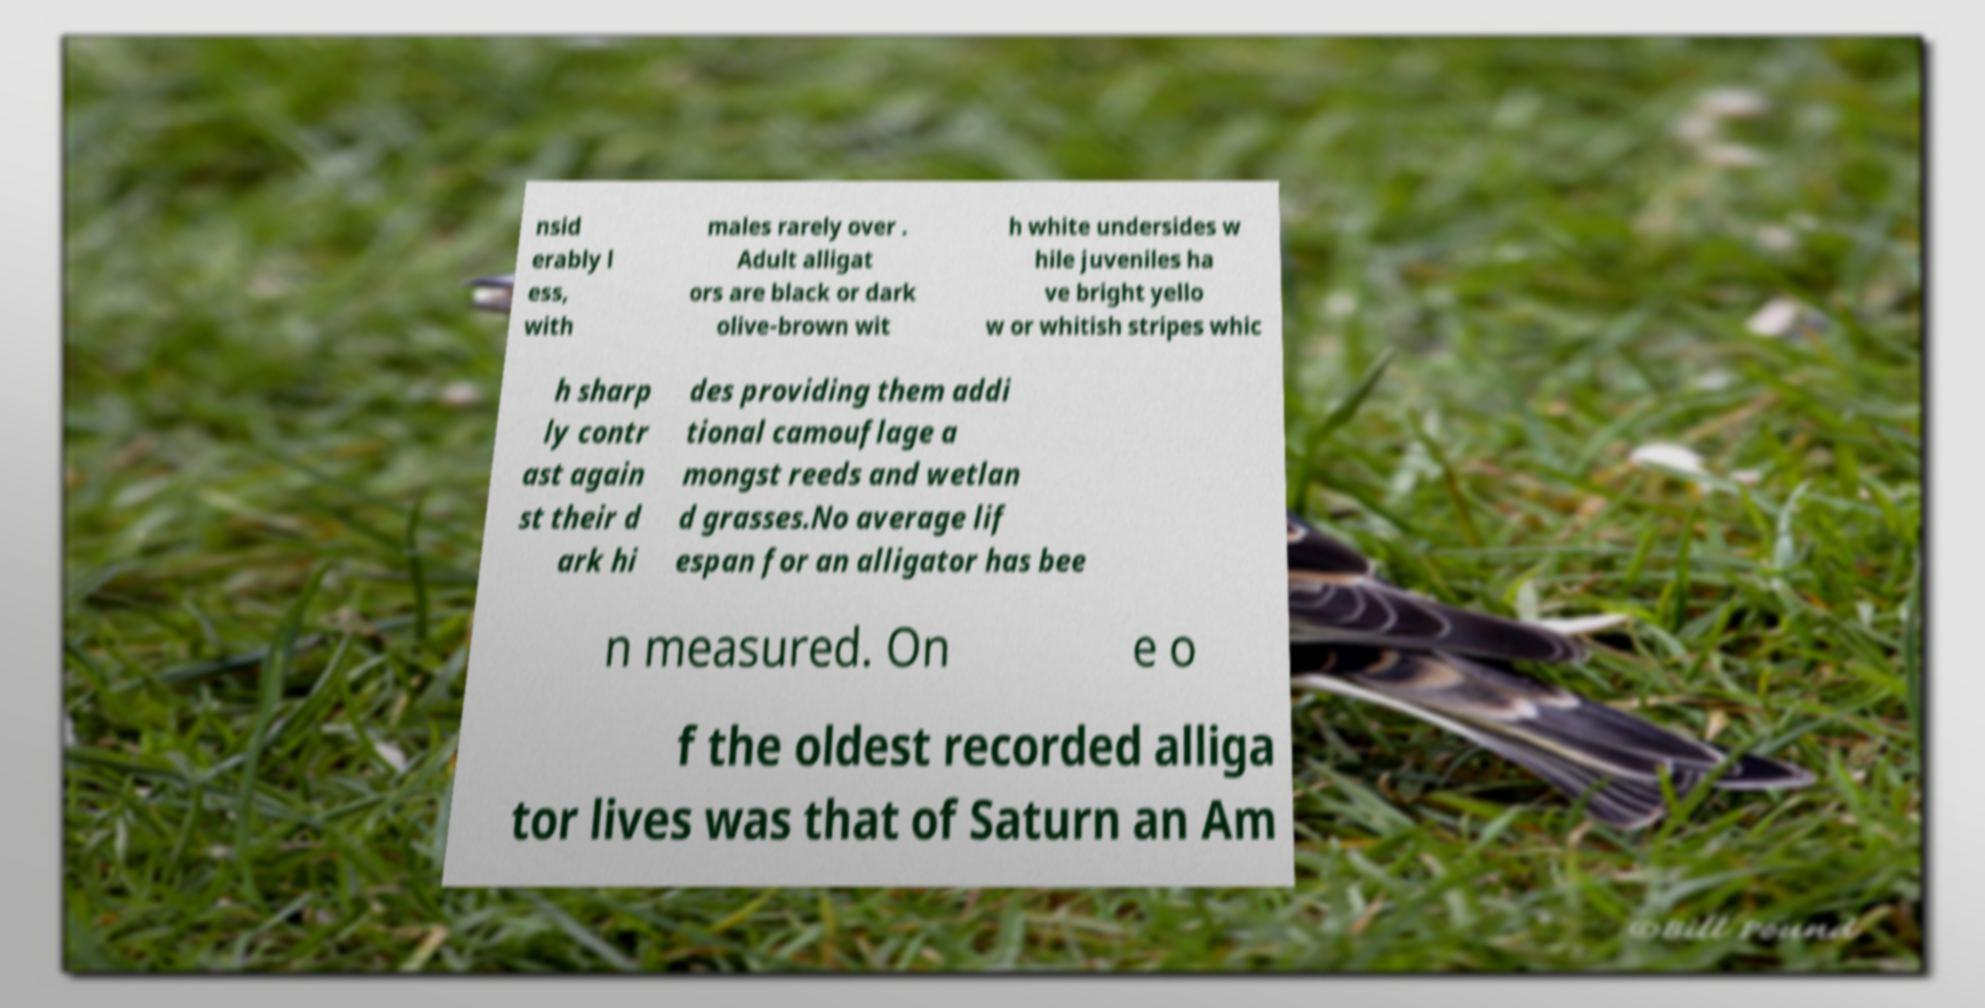Could you assist in decoding the text presented in this image and type it out clearly? nsid erably l ess, with males rarely over . Adult alligat ors are black or dark olive-brown wit h white undersides w hile juveniles ha ve bright yello w or whitish stripes whic h sharp ly contr ast again st their d ark hi des providing them addi tional camouflage a mongst reeds and wetlan d grasses.No average lif espan for an alligator has bee n measured. On e o f the oldest recorded alliga tor lives was that of Saturn an Am 